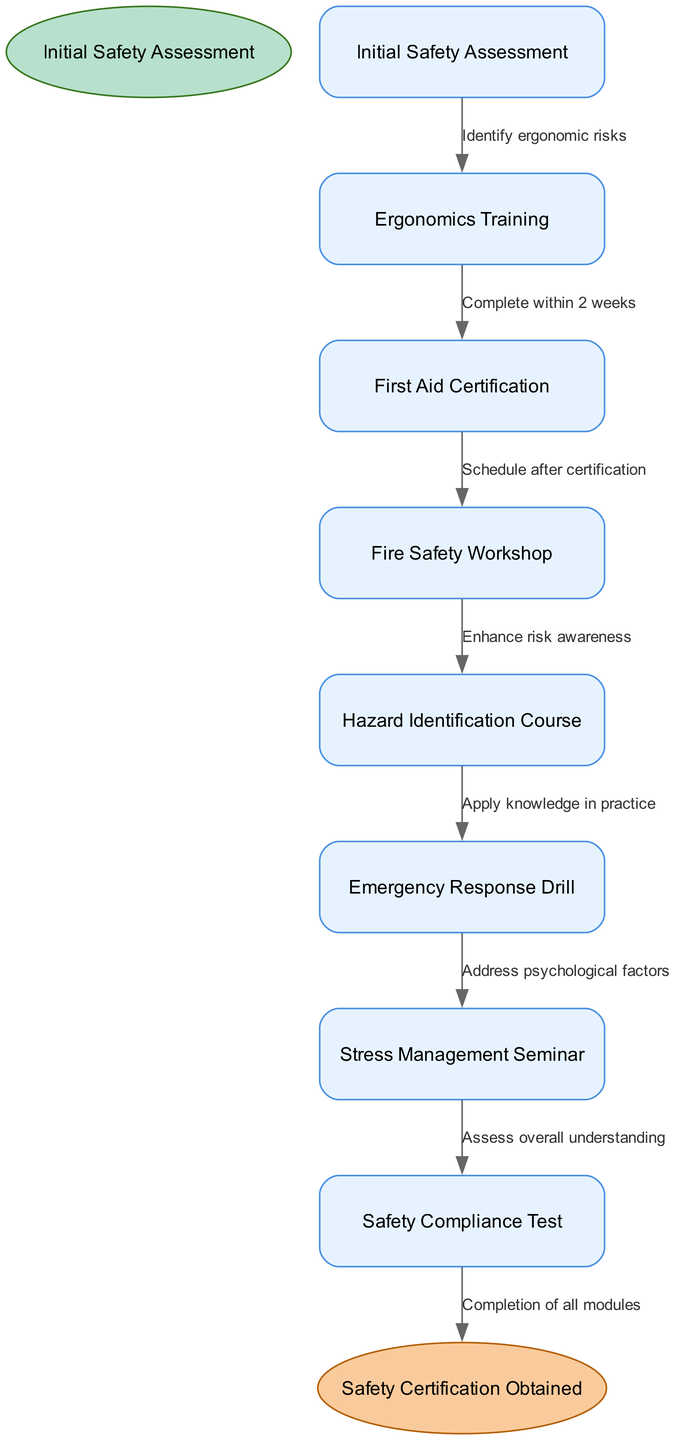What is the starting point of the pathway? The initial node in the diagram is labeled "Initial Safety Assessment," which indicates the starting point of the entire pathway.
Answer: Initial Safety Assessment How many training courses are included in the pathway? There are seven nodes representing different training courses or seminars in the pathway, namely Ergonomics Training, First Aid Certification, Fire Safety Workshop, Hazard Identification Course, Emergency Response Drill, Stress Management Seminar, and Safety Compliance Test.
Answer: 7 What is the last course a participant will complete before obtaining certification? The final node before reaching the end labeled "Safety Certification Obtained" is "Stress Management Seminar." Thus, this is the last training completed before certification.
Answer: Stress Management Seminar Which course emphasizes applying knowledge in practice? The course labeled "Hazard Identification Course" specifically mentions that it is intended for applying learned knowledge in practical scenarios, leading to the "Emergency Response Drill."
Answer: Hazard Identification Course What relationship exists between First Aid Certification and Fire Safety Workshop? The edge between these two nodes indicates that a participant should "Schedule after certification," meaning there is a sequential relationship where Fire Safety Workshop follows First Aid Certification.
Answer: Schedule after certification How does a participant address psychological factors during the pathway? The pathway includes a "Stress Management Seminar" that specifically focuses on addressing psychological factors related to workplace safety, following the Emergency Response Drill.
Answer: Stress Management Seminar What is the final step in the pathway after completing all modules? The final step in the pathway, represented by an edge from the last training course to the end node, indicates "Completion of all modules" leading to "Safety Certification Obtained."
Answer: Completion of all modules Which training directly follows Ergonomics Training? According to the edges, the training that follows Ergonomics Training is "First Aid Certification," which must be completed within a specified timeframe.
Answer: First Aid Certification How does the pathway enhance risk awareness? The transition from "Fire Safety Workshop" to "Hazard Identification Course" indicates that the workshop is aimed at enhancing risk awareness, allowing participants to better identify hazards in their work environment.
Answer: Enhance risk awareness 